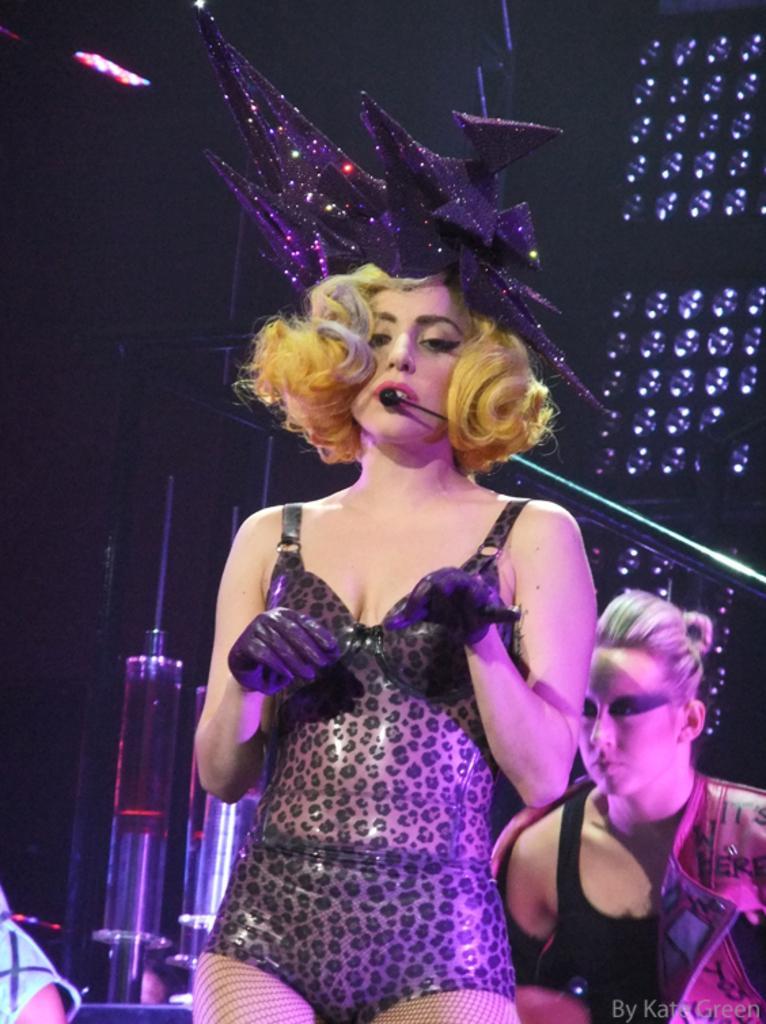Can you describe this image briefly? In this image I can see the person standing and the person is wearing black color dress and I can the microphone. Background I can see few lights. 